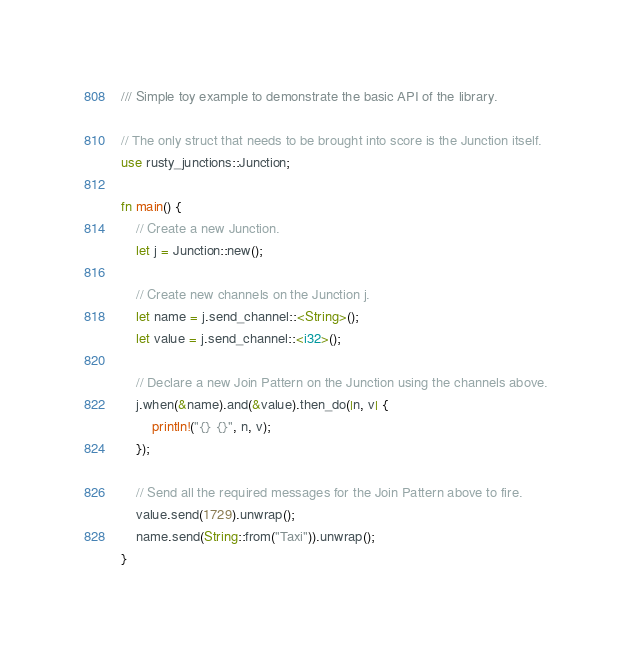<code> <loc_0><loc_0><loc_500><loc_500><_Rust_>/// Simple toy example to demonstrate the basic API of the library.

// The only struct that needs to be brought into score is the Junction itself.
use rusty_junctions::Junction;

fn main() {
    // Create a new Junction.
    let j = Junction::new();

    // Create new channels on the Junction j.
    let name = j.send_channel::<String>();
    let value = j.send_channel::<i32>();

    // Declare a new Join Pattern on the Junction using the channels above.
    j.when(&name).and(&value).then_do(|n, v| {
        println!("{} {}", n, v);
    });

    // Send all the required messages for the Join Pattern above to fire.
    value.send(1729).unwrap();
    name.send(String::from("Taxi")).unwrap();
}
</code> 